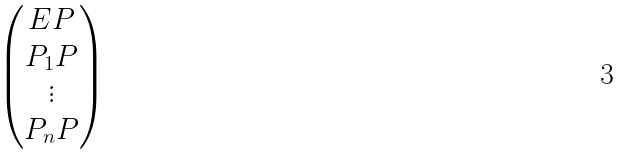<formula> <loc_0><loc_0><loc_500><loc_500>\begin{pmatrix} E P \\ P _ { 1 } P \\ \vdots \\ P _ { n } P \end{pmatrix}</formula> 